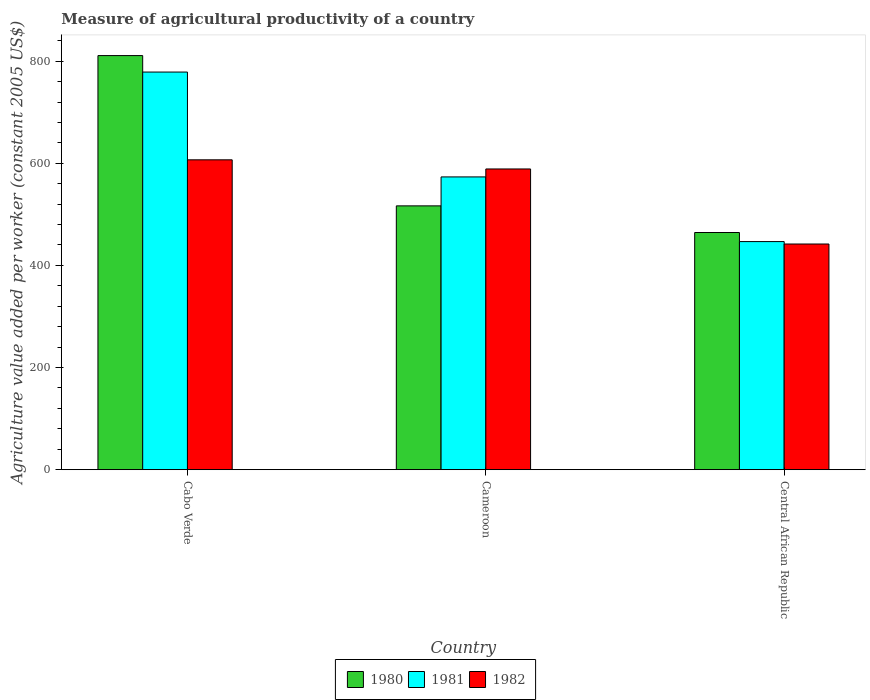How many different coloured bars are there?
Your answer should be very brief. 3. Are the number of bars per tick equal to the number of legend labels?
Offer a very short reply. Yes. What is the label of the 1st group of bars from the left?
Your response must be concise. Cabo Verde. What is the measure of agricultural productivity in 1981 in Central African Republic?
Your answer should be very brief. 446.67. Across all countries, what is the maximum measure of agricultural productivity in 1982?
Your response must be concise. 606.77. Across all countries, what is the minimum measure of agricultural productivity in 1981?
Your answer should be compact. 446.67. In which country was the measure of agricultural productivity in 1982 maximum?
Provide a short and direct response. Cabo Verde. In which country was the measure of agricultural productivity in 1980 minimum?
Make the answer very short. Central African Republic. What is the total measure of agricultural productivity in 1981 in the graph?
Keep it short and to the point. 1798.62. What is the difference between the measure of agricultural productivity in 1981 in Cameroon and that in Central African Republic?
Your answer should be very brief. 126.65. What is the difference between the measure of agricultural productivity in 1980 in Cameroon and the measure of agricultural productivity in 1982 in Cabo Verde?
Your answer should be compact. -90.16. What is the average measure of agricultural productivity in 1981 per country?
Make the answer very short. 599.54. What is the difference between the measure of agricultural productivity of/in 1982 and measure of agricultural productivity of/in 1980 in Central African Republic?
Your answer should be very brief. -22.52. What is the ratio of the measure of agricultural productivity in 1980 in Cabo Verde to that in Cameroon?
Ensure brevity in your answer.  1.57. Is the difference between the measure of agricultural productivity in 1982 in Cabo Verde and Cameroon greater than the difference between the measure of agricultural productivity in 1980 in Cabo Verde and Cameroon?
Give a very brief answer. No. What is the difference between the highest and the second highest measure of agricultural productivity in 1980?
Your answer should be compact. -346.46. What is the difference between the highest and the lowest measure of agricultural productivity in 1981?
Make the answer very short. 331.96. Is the sum of the measure of agricultural productivity in 1981 in Cabo Verde and Cameroon greater than the maximum measure of agricultural productivity in 1980 across all countries?
Keep it short and to the point. Yes. Does the graph contain any zero values?
Offer a very short reply. No. How many legend labels are there?
Provide a short and direct response. 3. What is the title of the graph?
Your response must be concise. Measure of agricultural productivity of a country. What is the label or title of the X-axis?
Your answer should be very brief. Country. What is the label or title of the Y-axis?
Your answer should be compact. Agriculture value added per worker (constant 2005 US$). What is the Agriculture value added per worker (constant 2005 US$) of 1980 in Cabo Verde?
Your response must be concise. 810.9. What is the Agriculture value added per worker (constant 2005 US$) in 1981 in Cabo Verde?
Your response must be concise. 778.63. What is the Agriculture value added per worker (constant 2005 US$) in 1982 in Cabo Verde?
Your response must be concise. 606.77. What is the Agriculture value added per worker (constant 2005 US$) of 1980 in Cameroon?
Offer a very short reply. 516.62. What is the Agriculture value added per worker (constant 2005 US$) of 1981 in Cameroon?
Give a very brief answer. 573.32. What is the Agriculture value added per worker (constant 2005 US$) in 1982 in Cameroon?
Offer a terse response. 588.87. What is the Agriculture value added per worker (constant 2005 US$) of 1980 in Central African Republic?
Your answer should be very brief. 464.44. What is the Agriculture value added per worker (constant 2005 US$) of 1981 in Central African Republic?
Provide a short and direct response. 446.67. What is the Agriculture value added per worker (constant 2005 US$) of 1982 in Central African Republic?
Provide a short and direct response. 441.92. Across all countries, what is the maximum Agriculture value added per worker (constant 2005 US$) of 1980?
Make the answer very short. 810.9. Across all countries, what is the maximum Agriculture value added per worker (constant 2005 US$) of 1981?
Your response must be concise. 778.63. Across all countries, what is the maximum Agriculture value added per worker (constant 2005 US$) in 1982?
Offer a terse response. 606.77. Across all countries, what is the minimum Agriculture value added per worker (constant 2005 US$) in 1980?
Your answer should be very brief. 464.44. Across all countries, what is the minimum Agriculture value added per worker (constant 2005 US$) in 1981?
Keep it short and to the point. 446.67. Across all countries, what is the minimum Agriculture value added per worker (constant 2005 US$) in 1982?
Your answer should be compact. 441.92. What is the total Agriculture value added per worker (constant 2005 US$) of 1980 in the graph?
Your answer should be very brief. 1791.95. What is the total Agriculture value added per worker (constant 2005 US$) in 1981 in the graph?
Provide a succinct answer. 1798.62. What is the total Agriculture value added per worker (constant 2005 US$) of 1982 in the graph?
Your answer should be compact. 1637.56. What is the difference between the Agriculture value added per worker (constant 2005 US$) in 1980 in Cabo Verde and that in Cameroon?
Keep it short and to the point. 294.28. What is the difference between the Agriculture value added per worker (constant 2005 US$) in 1981 in Cabo Verde and that in Cameroon?
Offer a terse response. 205.31. What is the difference between the Agriculture value added per worker (constant 2005 US$) of 1982 in Cabo Verde and that in Cameroon?
Keep it short and to the point. 17.9. What is the difference between the Agriculture value added per worker (constant 2005 US$) in 1980 in Cabo Verde and that in Central African Republic?
Keep it short and to the point. 346.46. What is the difference between the Agriculture value added per worker (constant 2005 US$) of 1981 in Cabo Verde and that in Central African Republic?
Your answer should be compact. 331.96. What is the difference between the Agriculture value added per worker (constant 2005 US$) in 1982 in Cabo Verde and that in Central African Republic?
Your response must be concise. 164.85. What is the difference between the Agriculture value added per worker (constant 2005 US$) of 1980 in Cameroon and that in Central African Republic?
Provide a succinct answer. 52.18. What is the difference between the Agriculture value added per worker (constant 2005 US$) of 1981 in Cameroon and that in Central African Republic?
Offer a terse response. 126.65. What is the difference between the Agriculture value added per worker (constant 2005 US$) of 1982 in Cameroon and that in Central African Republic?
Provide a short and direct response. 146.95. What is the difference between the Agriculture value added per worker (constant 2005 US$) in 1980 in Cabo Verde and the Agriculture value added per worker (constant 2005 US$) in 1981 in Cameroon?
Your answer should be compact. 237.58. What is the difference between the Agriculture value added per worker (constant 2005 US$) of 1980 in Cabo Verde and the Agriculture value added per worker (constant 2005 US$) of 1982 in Cameroon?
Give a very brief answer. 222.02. What is the difference between the Agriculture value added per worker (constant 2005 US$) in 1981 in Cabo Verde and the Agriculture value added per worker (constant 2005 US$) in 1982 in Cameroon?
Your answer should be compact. 189.76. What is the difference between the Agriculture value added per worker (constant 2005 US$) in 1980 in Cabo Verde and the Agriculture value added per worker (constant 2005 US$) in 1981 in Central African Republic?
Provide a short and direct response. 364.23. What is the difference between the Agriculture value added per worker (constant 2005 US$) in 1980 in Cabo Verde and the Agriculture value added per worker (constant 2005 US$) in 1982 in Central African Republic?
Provide a short and direct response. 368.98. What is the difference between the Agriculture value added per worker (constant 2005 US$) of 1981 in Cabo Verde and the Agriculture value added per worker (constant 2005 US$) of 1982 in Central African Republic?
Provide a short and direct response. 336.71. What is the difference between the Agriculture value added per worker (constant 2005 US$) in 1980 in Cameroon and the Agriculture value added per worker (constant 2005 US$) in 1981 in Central African Republic?
Your response must be concise. 69.94. What is the difference between the Agriculture value added per worker (constant 2005 US$) in 1980 in Cameroon and the Agriculture value added per worker (constant 2005 US$) in 1982 in Central African Republic?
Offer a terse response. 74.7. What is the difference between the Agriculture value added per worker (constant 2005 US$) in 1981 in Cameroon and the Agriculture value added per worker (constant 2005 US$) in 1982 in Central African Republic?
Offer a terse response. 131.4. What is the average Agriculture value added per worker (constant 2005 US$) of 1980 per country?
Your response must be concise. 597.32. What is the average Agriculture value added per worker (constant 2005 US$) of 1981 per country?
Offer a very short reply. 599.54. What is the average Agriculture value added per worker (constant 2005 US$) in 1982 per country?
Give a very brief answer. 545.85. What is the difference between the Agriculture value added per worker (constant 2005 US$) of 1980 and Agriculture value added per worker (constant 2005 US$) of 1981 in Cabo Verde?
Give a very brief answer. 32.27. What is the difference between the Agriculture value added per worker (constant 2005 US$) in 1980 and Agriculture value added per worker (constant 2005 US$) in 1982 in Cabo Verde?
Your response must be concise. 204.13. What is the difference between the Agriculture value added per worker (constant 2005 US$) of 1981 and Agriculture value added per worker (constant 2005 US$) of 1982 in Cabo Verde?
Provide a short and direct response. 171.86. What is the difference between the Agriculture value added per worker (constant 2005 US$) of 1980 and Agriculture value added per worker (constant 2005 US$) of 1981 in Cameroon?
Offer a terse response. -56.7. What is the difference between the Agriculture value added per worker (constant 2005 US$) of 1980 and Agriculture value added per worker (constant 2005 US$) of 1982 in Cameroon?
Provide a succinct answer. -72.26. What is the difference between the Agriculture value added per worker (constant 2005 US$) of 1981 and Agriculture value added per worker (constant 2005 US$) of 1982 in Cameroon?
Your answer should be very brief. -15.55. What is the difference between the Agriculture value added per worker (constant 2005 US$) in 1980 and Agriculture value added per worker (constant 2005 US$) in 1981 in Central African Republic?
Your answer should be compact. 17.77. What is the difference between the Agriculture value added per worker (constant 2005 US$) of 1980 and Agriculture value added per worker (constant 2005 US$) of 1982 in Central African Republic?
Provide a short and direct response. 22.52. What is the difference between the Agriculture value added per worker (constant 2005 US$) in 1981 and Agriculture value added per worker (constant 2005 US$) in 1982 in Central African Republic?
Ensure brevity in your answer.  4.75. What is the ratio of the Agriculture value added per worker (constant 2005 US$) in 1980 in Cabo Verde to that in Cameroon?
Your response must be concise. 1.57. What is the ratio of the Agriculture value added per worker (constant 2005 US$) of 1981 in Cabo Verde to that in Cameroon?
Offer a very short reply. 1.36. What is the ratio of the Agriculture value added per worker (constant 2005 US$) in 1982 in Cabo Verde to that in Cameroon?
Provide a succinct answer. 1.03. What is the ratio of the Agriculture value added per worker (constant 2005 US$) in 1980 in Cabo Verde to that in Central African Republic?
Your answer should be very brief. 1.75. What is the ratio of the Agriculture value added per worker (constant 2005 US$) of 1981 in Cabo Verde to that in Central African Republic?
Your response must be concise. 1.74. What is the ratio of the Agriculture value added per worker (constant 2005 US$) of 1982 in Cabo Verde to that in Central African Republic?
Keep it short and to the point. 1.37. What is the ratio of the Agriculture value added per worker (constant 2005 US$) in 1980 in Cameroon to that in Central African Republic?
Keep it short and to the point. 1.11. What is the ratio of the Agriculture value added per worker (constant 2005 US$) of 1981 in Cameroon to that in Central African Republic?
Offer a very short reply. 1.28. What is the ratio of the Agriculture value added per worker (constant 2005 US$) of 1982 in Cameroon to that in Central African Republic?
Make the answer very short. 1.33. What is the difference between the highest and the second highest Agriculture value added per worker (constant 2005 US$) of 1980?
Ensure brevity in your answer.  294.28. What is the difference between the highest and the second highest Agriculture value added per worker (constant 2005 US$) of 1981?
Provide a succinct answer. 205.31. What is the difference between the highest and the second highest Agriculture value added per worker (constant 2005 US$) in 1982?
Provide a succinct answer. 17.9. What is the difference between the highest and the lowest Agriculture value added per worker (constant 2005 US$) of 1980?
Ensure brevity in your answer.  346.46. What is the difference between the highest and the lowest Agriculture value added per worker (constant 2005 US$) in 1981?
Make the answer very short. 331.96. What is the difference between the highest and the lowest Agriculture value added per worker (constant 2005 US$) in 1982?
Provide a short and direct response. 164.85. 